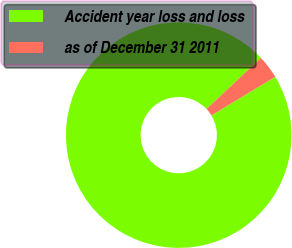<chart> <loc_0><loc_0><loc_500><loc_500><pie_chart><fcel>Accident year loss and loss<fcel>as of December 31 2011<nl><fcel>96.64%<fcel>3.36%<nl></chart> 